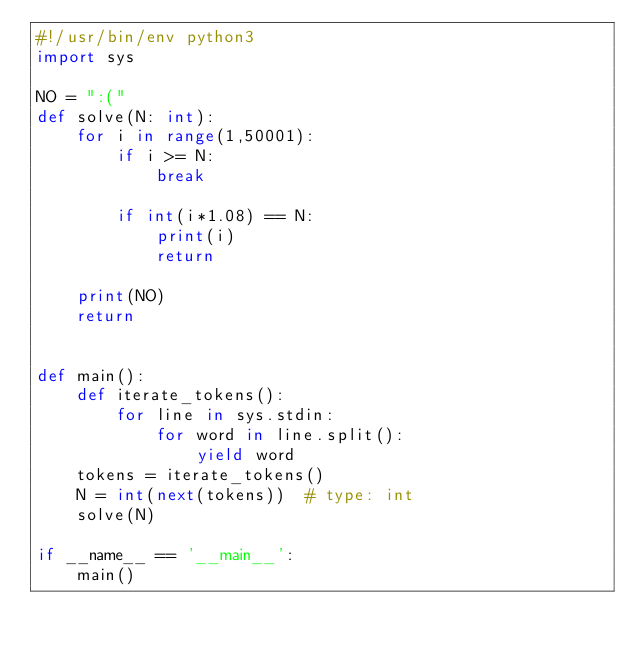Convert code to text. <code><loc_0><loc_0><loc_500><loc_500><_Python_>#!/usr/bin/env python3
import sys

NO = ":("
def solve(N: int):
    for i in range(1,50001):
        if i >= N:
            break

        if int(i*1.08) == N:
            print(i)
            return
    
    print(NO)
    return


def main():
    def iterate_tokens():
        for line in sys.stdin:
            for word in line.split():
                yield word
    tokens = iterate_tokens()
    N = int(next(tokens))  # type: int
    solve(N)

if __name__ == '__main__':
    main()
</code> 